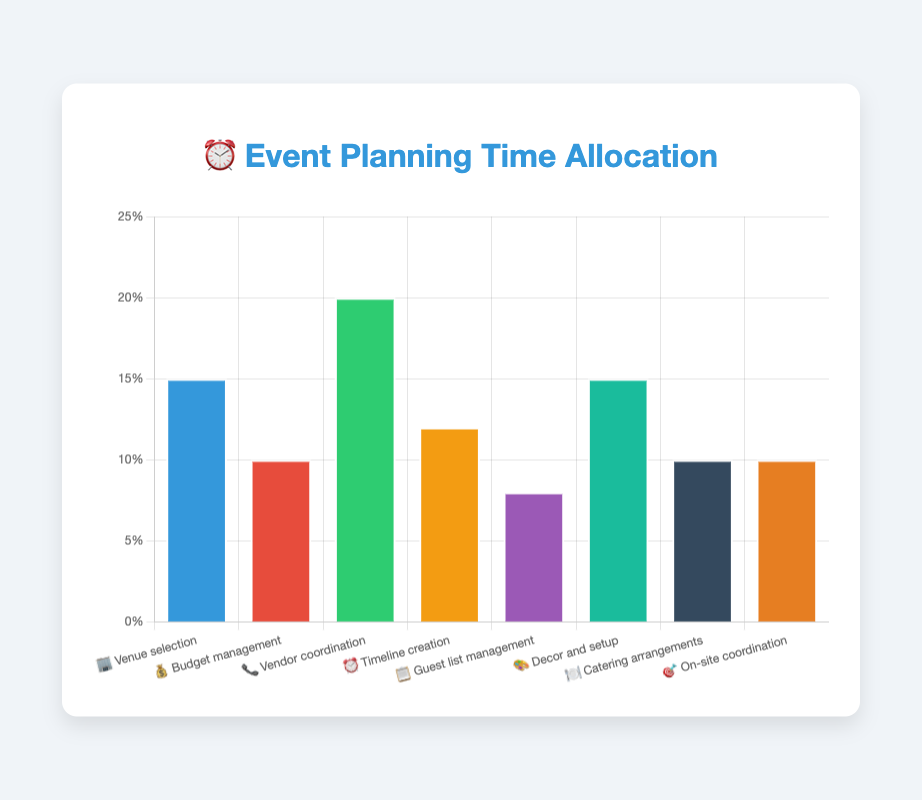Which task takes up the most time in event planning? The bar for "Vendor coordination" is the highest on the chart, indicating it has the largest time allocation.
Answer: Vendor coordination What is the total percentage of time spent on Venue selection and Decor and setup? The time allocation for "Venue selection" is 15%, and for "Decor and setup" it is also 15%. Adding these together gives 15% + 15% = 30%.
Answer: 30% How much time is allocated to Budget management compared to Catering arrangements? Both "Budget management" and "Catering arrangements" are allocated 10% each.
Answer: Equal Which task allocates more time: Timeline creation or Guest list management? "Timeline creation" is allocated 12%, while "Guest list management" is allocated 8%. Therefore, "Timeline creation" takes up more time.
Answer: Timeline creation What is the average time allocation among all tasks? Summing the percentages: 15% + 10% + 20% + 12% + 8% + 15% + 10% + 10% = 100%. There are 8 tasks, so the average is 100% / 8 = 12.5%.
Answer: 12.5% How does the time allocated to On-site coordination compare to that for Budget management? Both "On-site coordination" and "Budget management" are allocated 10%.
Answer: Equal What percentage of time is dedicated to tasks related to guest interaction and management (Guest list management and Catering arrangements)? "Guest list management" is 8% and "Catering arrangements" is 10%. The total is 8% + 10% = 18%.
Answer: 18% Which tasks are allocated the same percentage of time? "Venue selection" and "Decor and setup" are both allocated 15%, while "Budget management," "Catering arrangements," and "On-site coordination" are each allocated 10%.
Answer: Venue selection and Decor and setup; Budget management, Catering arrangements, and On-site coordination What is the difference in time allocation between the task with the highest percentage and the one with the lowest? "Vendor coordination" has the highest allocation at 20%, while "Guest list management" has the lowest at 8%. The difference is 20% - 8% = 12%.
Answer: 12% If you were to decrease the time spent on Vendor coordination by half and redistribute that time equally to the remaining tasks, how much time would each of the other tasks gain? "Vendor coordination" is 20%. Halving it gives 10%. There are 7 other tasks. Redistributing the 10% equally means each task gains 10% / 7 ≈ 1.43%.
Answer: 1.43% 